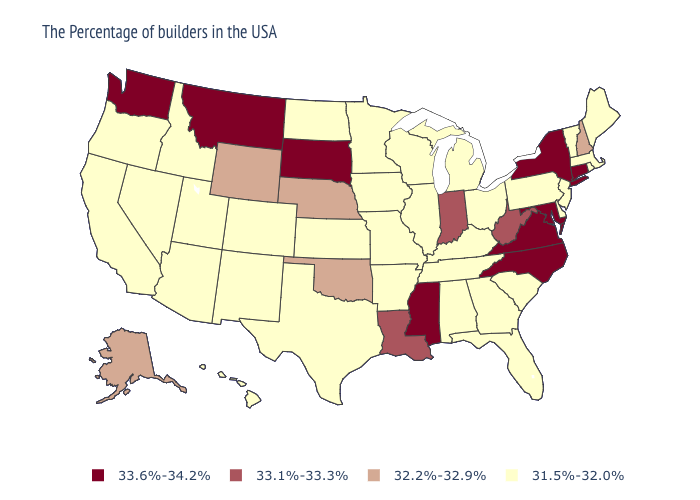What is the value of New Mexico?
Short answer required. 31.5%-32.0%. Which states have the lowest value in the West?
Concise answer only. Colorado, New Mexico, Utah, Arizona, Idaho, Nevada, California, Oregon, Hawaii. Name the states that have a value in the range 32.2%-32.9%?
Be succinct. New Hampshire, Nebraska, Oklahoma, Wyoming, Alaska. Does California have the lowest value in the West?
Answer briefly. Yes. Is the legend a continuous bar?
Short answer required. No. Among the states that border Texas , which have the highest value?
Short answer required. Louisiana. Which states have the lowest value in the MidWest?
Concise answer only. Ohio, Michigan, Wisconsin, Illinois, Missouri, Minnesota, Iowa, Kansas, North Dakota. Name the states that have a value in the range 33.6%-34.2%?
Answer briefly. Connecticut, New York, Maryland, Virginia, North Carolina, Mississippi, South Dakota, Montana, Washington. What is the highest value in the USA?
Be succinct. 33.6%-34.2%. How many symbols are there in the legend?
Quick response, please. 4. Does the map have missing data?
Write a very short answer. No. Name the states that have a value in the range 31.5%-32.0%?
Keep it brief. Maine, Massachusetts, Rhode Island, Vermont, New Jersey, Delaware, Pennsylvania, South Carolina, Ohio, Florida, Georgia, Michigan, Kentucky, Alabama, Tennessee, Wisconsin, Illinois, Missouri, Arkansas, Minnesota, Iowa, Kansas, Texas, North Dakota, Colorado, New Mexico, Utah, Arizona, Idaho, Nevada, California, Oregon, Hawaii. What is the lowest value in the USA?
Write a very short answer. 31.5%-32.0%. Name the states that have a value in the range 31.5%-32.0%?
Answer briefly. Maine, Massachusetts, Rhode Island, Vermont, New Jersey, Delaware, Pennsylvania, South Carolina, Ohio, Florida, Georgia, Michigan, Kentucky, Alabama, Tennessee, Wisconsin, Illinois, Missouri, Arkansas, Minnesota, Iowa, Kansas, Texas, North Dakota, Colorado, New Mexico, Utah, Arizona, Idaho, Nevada, California, Oregon, Hawaii. What is the value of Washington?
Quick response, please. 33.6%-34.2%. 